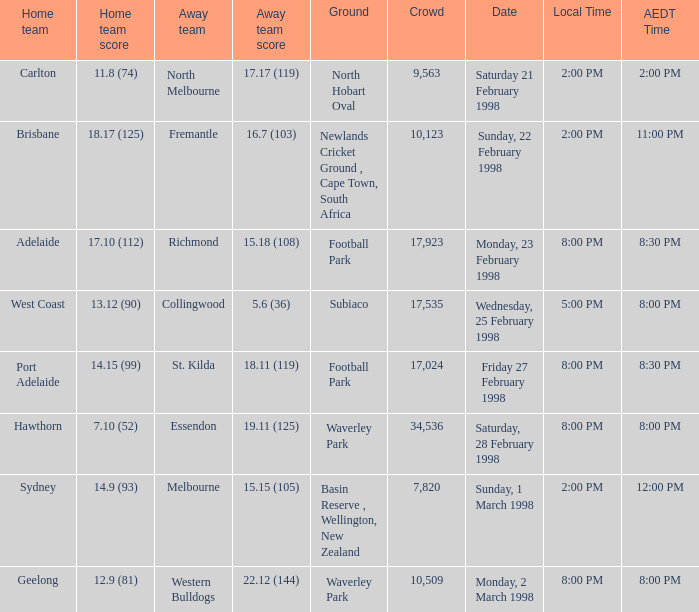Name the AEDT Time which has an Away team of collingwood? 8:00 PM. 